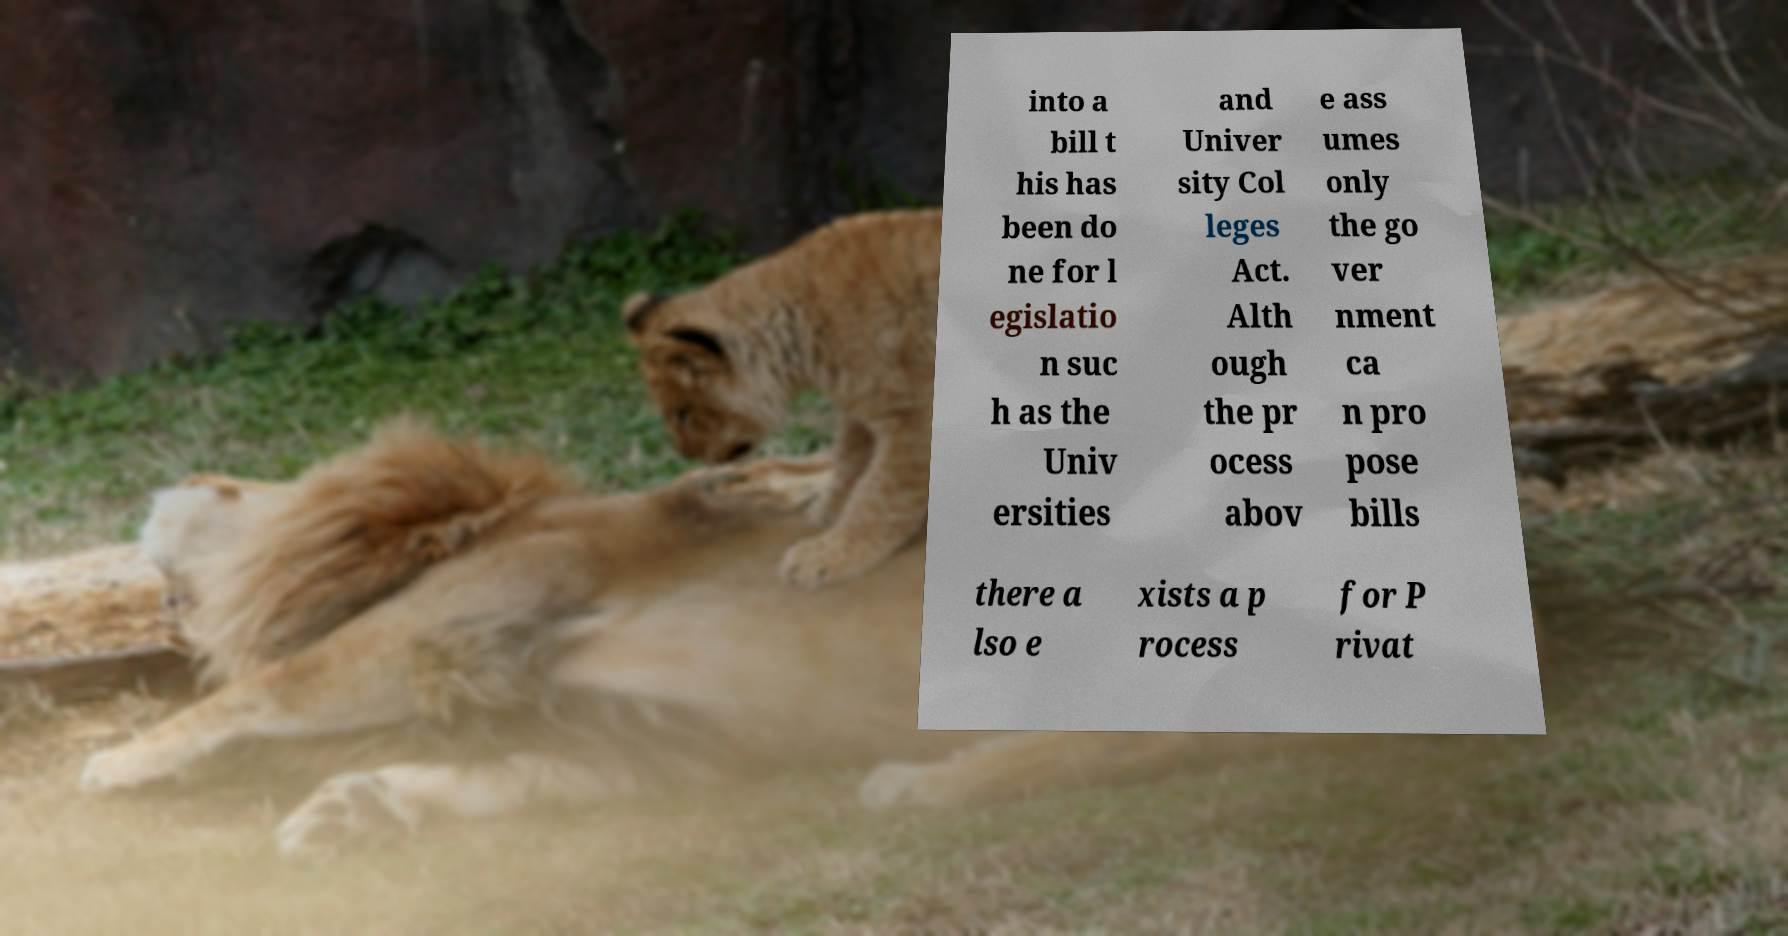Could you extract and type out the text from this image? into a bill t his has been do ne for l egislatio n suc h as the Univ ersities and Univer sity Col leges Act. Alth ough the pr ocess abov e ass umes only the go ver nment ca n pro pose bills there a lso e xists a p rocess for P rivat 